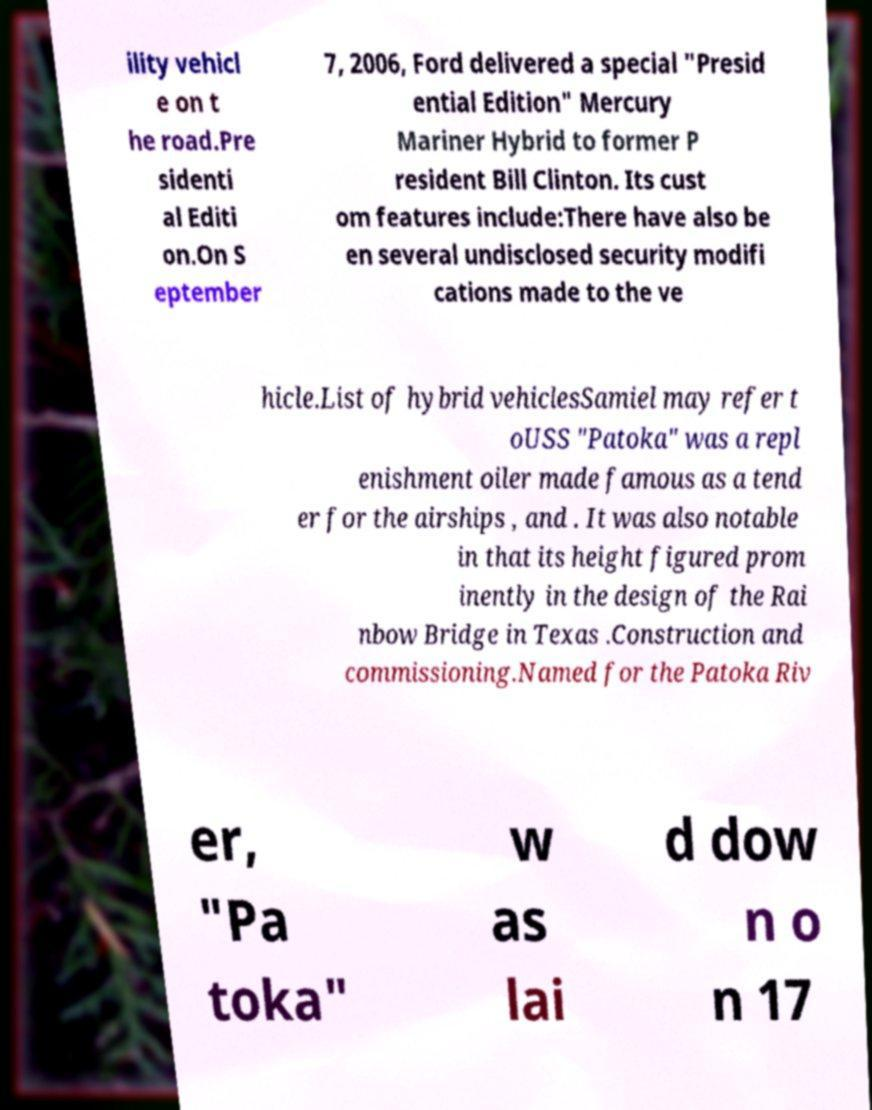Please read and relay the text visible in this image. What does it say? ility vehicl e on t he road.Pre sidenti al Editi on.On S eptember 7, 2006, Ford delivered a special "Presid ential Edition" Mercury Mariner Hybrid to former P resident Bill Clinton. Its cust om features include:There have also be en several undisclosed security modifi cations made to the ve hicle.List of hybrid vehiclesSamiel may refer t oUSS "Patoka" was a repl enishment oiler made famous as a tend er for the airships , and . It was also notable in that its height figured prom inently in the design of the Rai nbow Bridge in Texas .Construction and commissioning.Named for the Patoka Riv er, "Pa toka" w as lai d dow n o n 17 